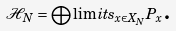<formula> <loc_0><loc_0><loc_500><loc_500>\mathcal { H } _ { N } = \bigoplus \lim i t s _ { x \in X _ { N } } P _ { x } \text {.}</formula> 